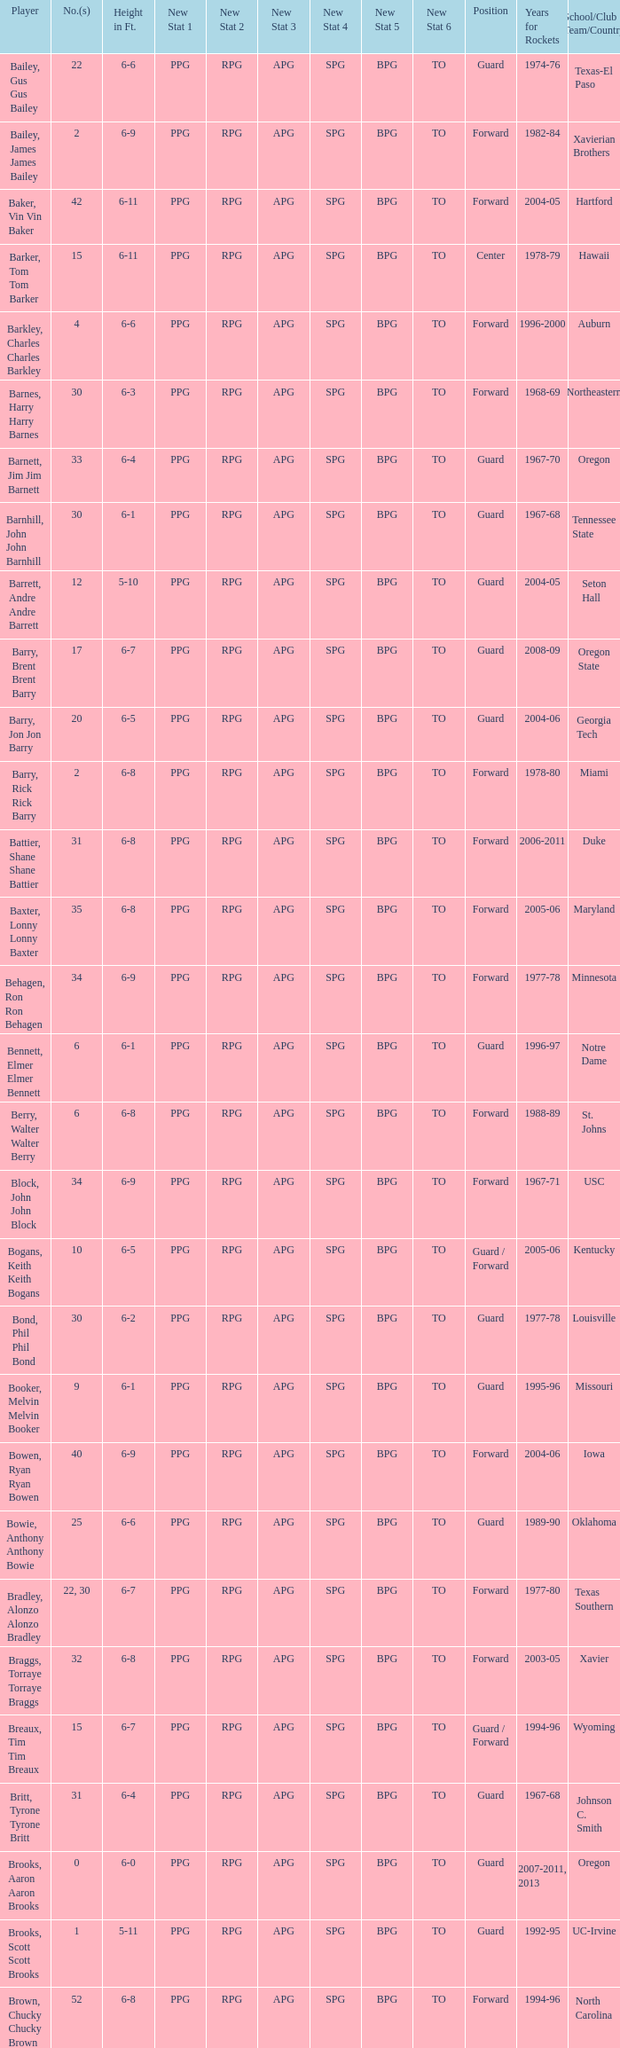What is the height of the player who attended Hartford? 6-11. 